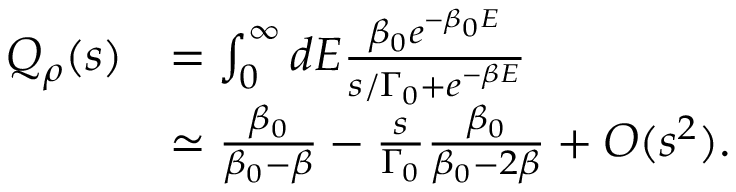<formula> <loc_0><loc_0><loc_500><loc_500>\begin{array} { r l } { Q _ { \rho } ( s ) } & { = \int _ { 0 } ^ { \infty } d E \frac { \beta _ { 0 } e ^ { - \beta _ { 0 } E } } { s / \Gamma _ { 0 } + e ^ { - \beta E } } } \\ & { \simeq \frac { \beta _ { 0 } } { \beta _ { 0 } - \beta } - \frac { s } { \Gamma _ { 0 } } \frac { \beta _ { 0 } } { \beta _ { 0 } - 2 \beta } + O ( s ^ { 2 } ) . } \end{array}</formula> 